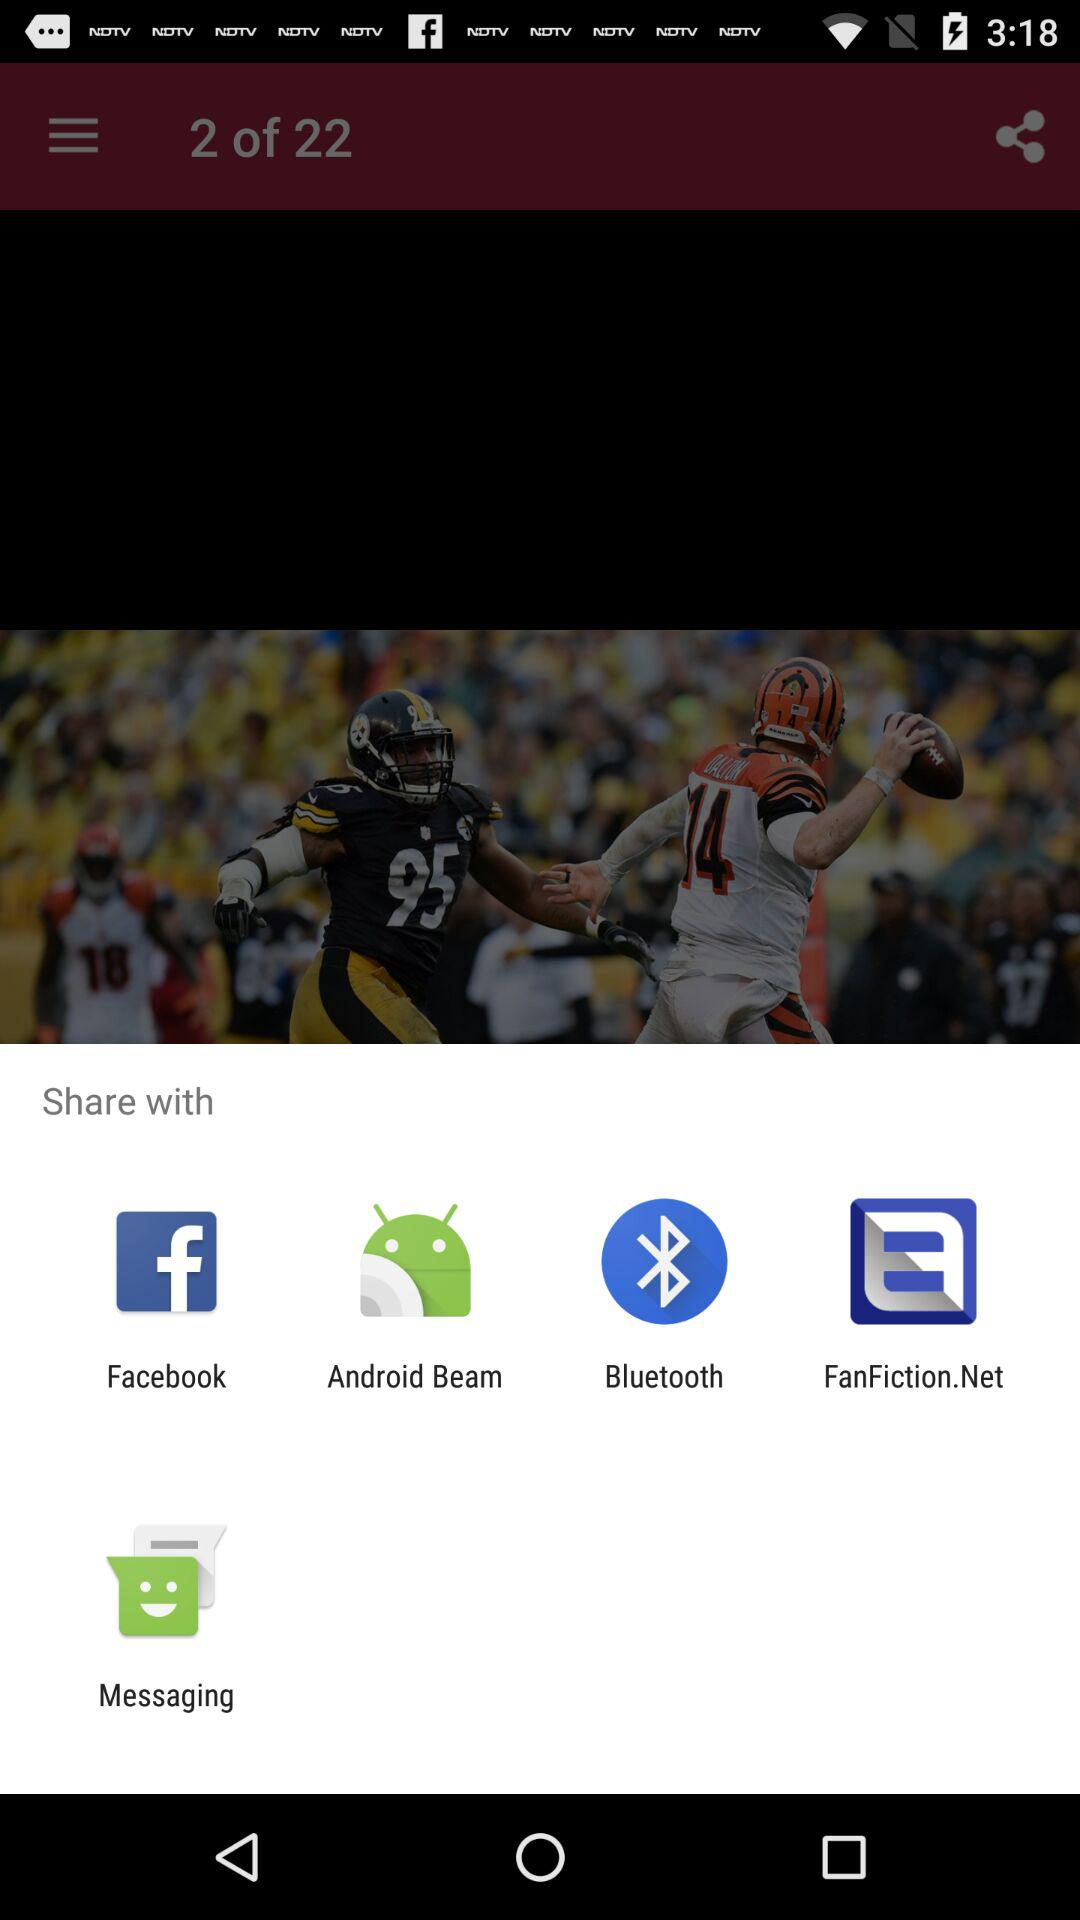What are some potential applications of the sharing options visible in the share menu? The sharing options include services that cater to different needs: Facebook is a social media platform for sharing with friends and followers, Android Beam allows for NFC-based close-range sharing with compatible devices, Bluetooth enables wireless file transfer between devices, FanFiction.Net is a niche platform where users can share stories, and Messaging is for sending content through text messages. Is fanfiction.net commonly included in share menus? Not typically. Fanfiction.net being included in a share menu is unusual, as share menus commonly feature more widely-used platforms. Its presence suggests the user has a specific app related to FanFiction.Net installed, which adds its own sharing capability. 